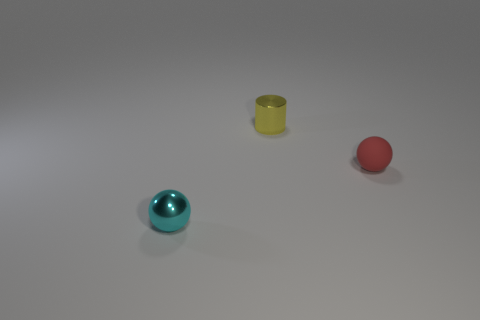There is another tiny shiny thing that is the same shape as the small red object; what color is it?
Ensure brevity in your answer.  Cyan. Is there anything else of the same color as the small cylinder?
Your answer should be compact. No. What number of other objects are the same material as the tiny yellow cylinder?
Your answer should be very brief. 1. How big is the red sphere?
Offer a very short reply. Small. Are there any other yellow objects that have the same shape as the small yellow thing?
Your answer should be compact. No. How many objects are either small red shiny things or tiny objects that are behind the red rubber object?
Make the answer very short. 1. There is a thing that is on the right side of the shiny cylinder; what is its color?
Provide a short and direct response. Red. Does the ball to the left of the tiny red object have the same size as the object that is on the right side of the tiny yellow thing?
Offer a terse response. Yes. Is there another cyan ball of the same size as the cyan sphere?
Ensure brevity in your answer.  No. How many cyan metallic spheres are to the left of the metal thing behind the tiny metal ball?
Your response must be concise. 1. 